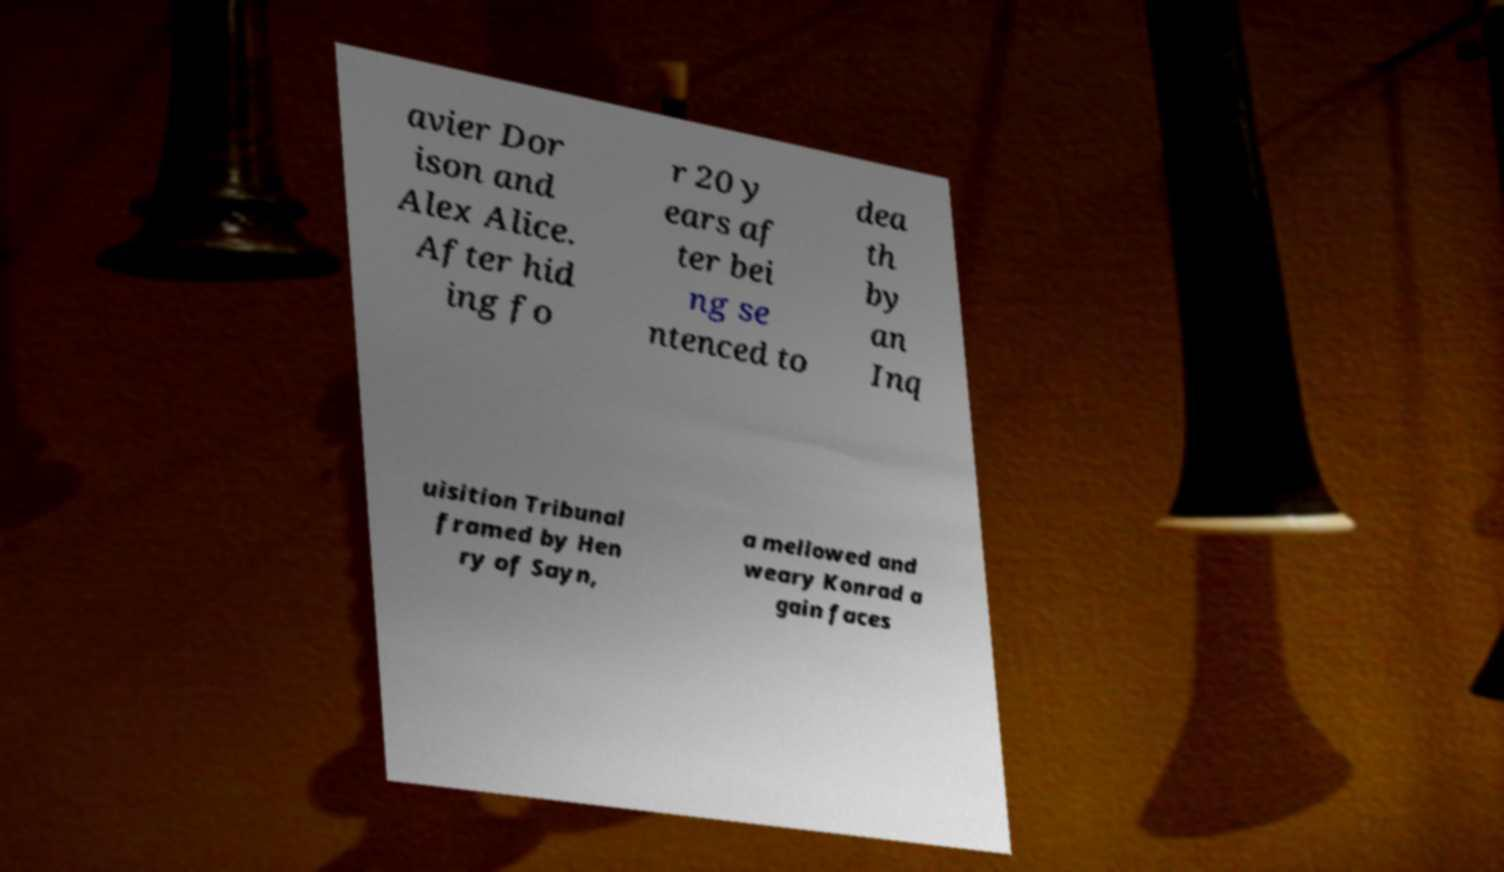There's text embedded in this image that I need extracted. Can you transcribe it verbatim? avier Dor ison and Alex Alice. After hid ing fo r 20 y ears af ter bei ng se ntenced to dea th by an Inq uisition Tribunal framed by Hen ry of Sayn, a mellowed and weary Konrad a gain faces 